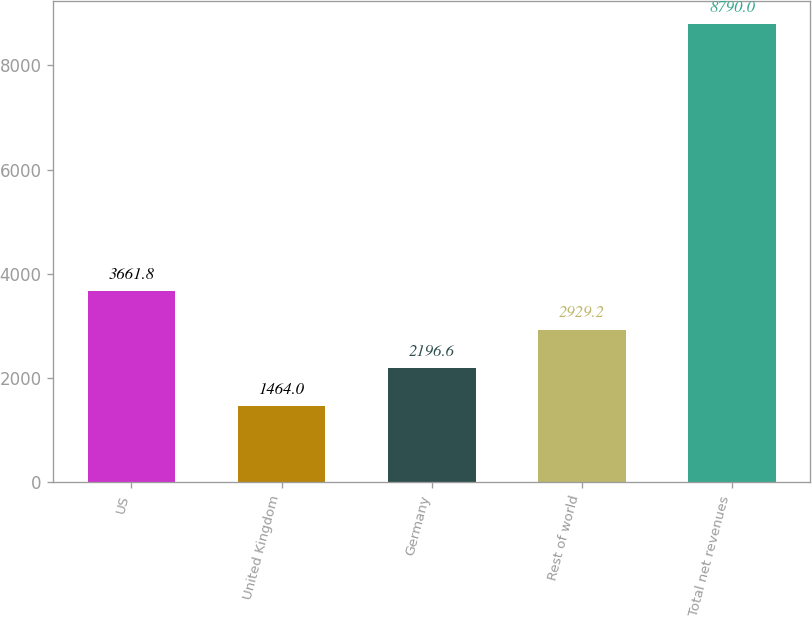<chart> <loc_0><loc_0><loc_500><loc_500><bar_chart><fcel>US<fcel>United Kingdom<fcel>Germany<fcel>Rest of world<fcel>Total net revenues<nl><fcel>3661.8<fcel>1464<fcel>2196.6<fcel>2929.2<fcel>8790<nl></chart> 